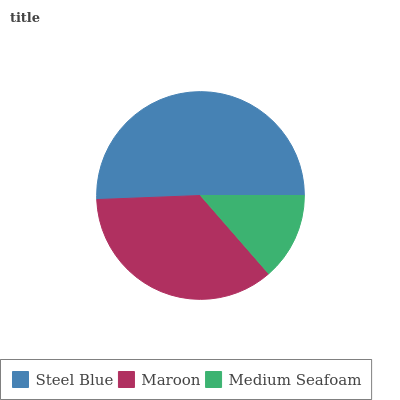Is Medium Seafoam the minimum?
Answer yes or no. Yes. Is Steel Blue the maximum?
Answer yes or no. Yes. Is Maroon the minimum?
Answer yes or no. No. Is Maroon the maximum?
Answer yes or no. No. Is Steel Blue greater than Maroon?
Answer yes or no. Yes. Is Maroon less than Steel Blue?
Answer yes or no. Yes. Is Maroon greater than Steel Blue?
Answer yes or no. No. Is Steel Blue less than Maroon?
Answer yes or no. No. Is Maroon the high median?
Answer yes or no. Yes. Is Maroon the low median?
Answer yes or no. Yes. Is Steel Blue the high median?
Answer yes or no. No. Is Steel Blue the low median?
Answer yes or no. No. 